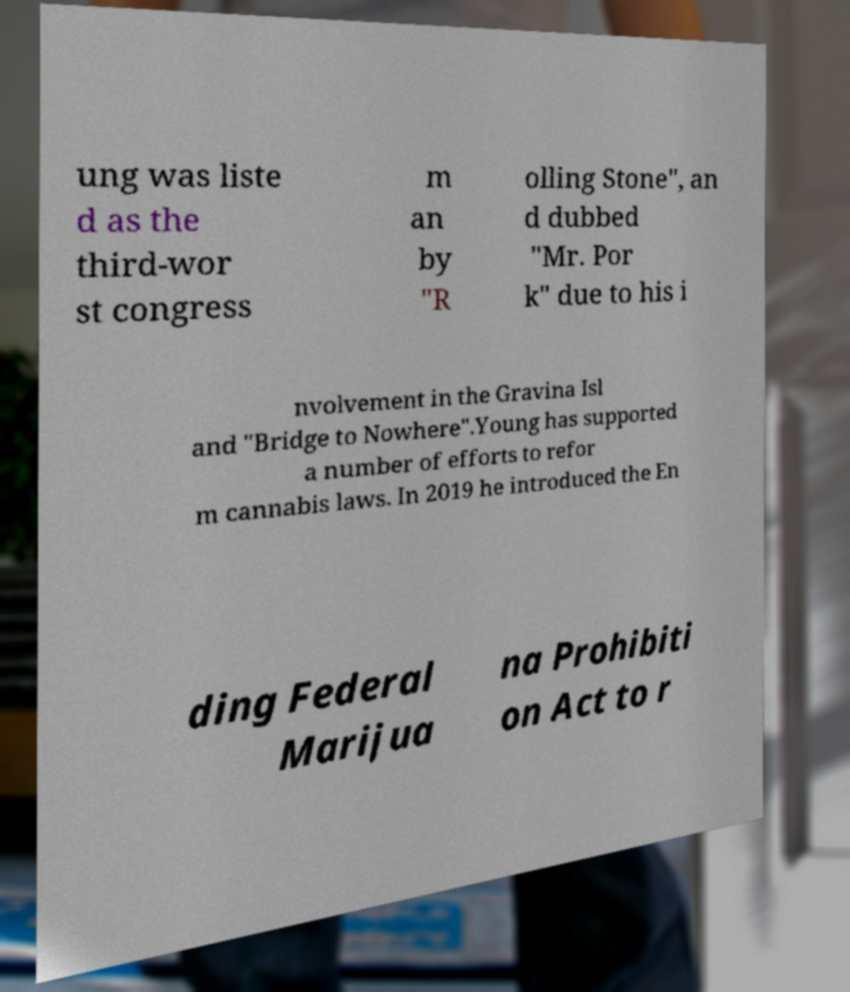Can you accurately transcribe the text from the provided image for me? ung was liste d as the third-wor st congress m an by "R olling Stone", an d dubbed "Mr. Por k" due to his i nvolvement in the Gravina Isl and "Bridge to Nowhere".Young has supported a number of efforts to refor m cannabis laws. In 2019 he introduced the En ding Federal Marijua na Prohibiti on Act to r 